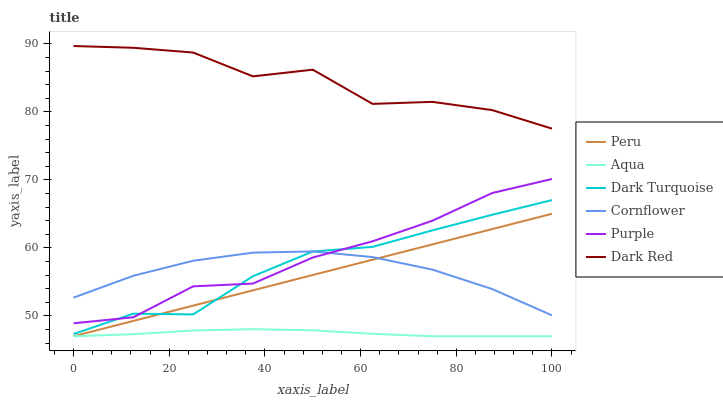Does Aqua have the minimum area under the curve?
Answer yes or no. Yes. Does Dark Red have the maximum area under the curve?
Answer yes or no. Yes. Does Purple have the minimum area under the curve?
Answer yes or no. No. Does Purple have the maximum area under the curve?
Answer yes or no. No. Is Peru the smoothest?
Answer yes or no. Yes. Is Dark Red the roughest?
Answer yes or no. Yes. Is Purple the smoothest?
Answer yes or no. No. Is Purple the roughest?
Answer yes or no. No. Does Aqua have the lowest value?
Answer yes or no. Yes. Does Purple have the lowest value?
Answer yes or no. No. Does Dark Red have the highest value?
Answer yes or no. Yes. Does Purple have the highest value?
Answer yes or no. No. Is Purple less than Dark Red?
Answer yes or no. Yes. Is Dark Red greater than Dark Turquoise?
Answer yes or no. Yes. Does Cornflower intersect Peru?
Answer yes or no. Yes. Is Cornflower less than Peru?
Answer yes or no. No. Is Cornflower greater than Peru?
Answer yes or no. No. Does Purple intersect Dark Red?
Answer yes or no. No. 